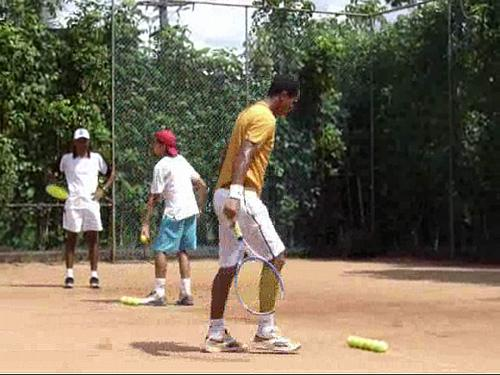What is the man looking down at? tennis balls 